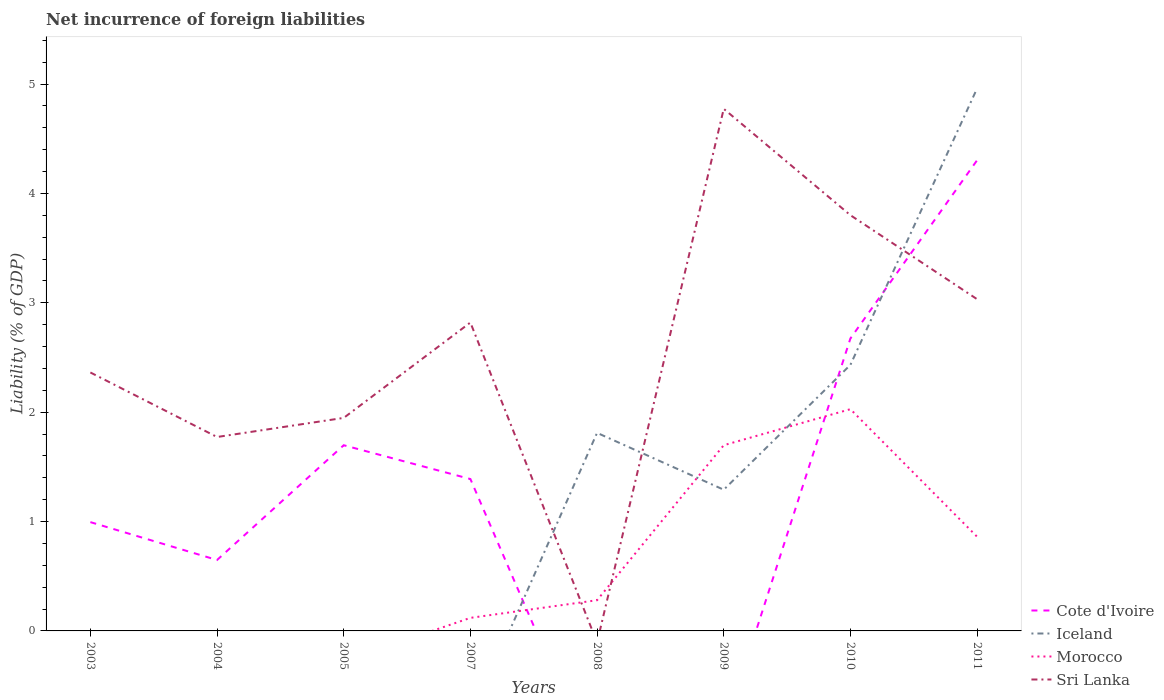Does the line corresponding to Iceland intersect with the line corresponding to Sri Lanka?
Provide a succinct answer. Yes. Is the number of lines equal to the number of legend labels?
Your answer should be very brief. No. What is the total net incurrence of foreign liabilities in Morocco in the graph?
Provide a succinct answer. -1.75. What is the difference between the highest and the second highest net incurrence of foreign liabilities in Cote d'Ivoire?
Make the answer very short. 4.3. How many lines are there?
Make the answer very short. 4. How many legend labels are there?
Give a very brief answer. 4. How are the legend labels stacked?
Keep it short and to the point. Vertical. What is the title of the graph?
Ensure brevity in your answer.  Net incurrence of foreign liabilities. What is the label or title of the Y-axis?
Make the answer very short. Liability (% of GDP). What is the Liability (% of GDP) in Cote d'Ivoire in 2003?
Your answer should be very brief. 0.99. What is the Liability (% of GDP) in Sri Lanka in 2003?
Provide a succinct answer. 2.36. What is the Liability (% of GDP) of Cote d'Ivoire in 2004?
Your response must be concise. 0.65. What is the Liability (% of GDP) of Iceland in 2004?
Your answer should be very brief. 0. What is the Liability (% of GDP) in Sri Lanka in 2004?
Provide a short and direct response. 1.77. What is the Liability (% of GDP) of Cote d'Ivoire in 2005?
Provide a succinct answer. 1.7. What is the Liability (% of GDP) in Morocco in 2005?
Your response must be concise. 0. What is the Liability (% of GDP) in Sri Lanka in 2005?
Provide a succinct answer. 1.95. What is the Liability (% of GDP) of Cote d'Ivoire in 2007?
Give a very brief answer. 1.39. What is the Liability (% of GDP) in Morocco in 2007?
Offer a terse response. 0.12. What is the Liability (% of GDP) of Sri Lanka in 2007?
Your response must be concise. 2.82. What is the Liability (% of GDP) in Cote d'Ivoire in 2008?
Keep it short and to the point. 0. What is the Liability (% of GDP) in Iceland in 2008?
Your response must be concise. 1.81. What is the Liability (% of GDP) in Morocco in 2008?
Offer a terse response. 0.28. What is the Liability (% of GDP) of Sri Lanka in 2008?
Ensure brevity in your answer.  0. What is the Liability (% of GDP) in Cote d'Ivoire in 2009?
Ensure brevity in your answer.  0. What is the Liability (% of GDP) of Iceland in 2009?
Offer a very short reply. 1.29. What is the Liability (% of GDP) in Morocco in 2009?
Offer a very short reply. 1.7. What is the Liability (% of GDP) of Sri Lanka in 2009?
Ensure brevity in your answer.  4.77. What is the Liability (% of GDP) of Cote d'Ivoire in 2010?
Ensure brevity in your answer.  2.67. What is the Liability (% of GDP) of Iceland in 2010?
Give a very brief answer. 2.43. What is the Liability (% of GDP) in Morocco in 2010?
Your answer should be compact. 2.03. What is the Liability (% of GDP) in Sri Lanka in 2010?
Your answer should be compact. 3.8. What is the Liability (% of GDP) of Cote d'Ivoire in 2011?
Your answer should be very brief. 4.3. What is the Liability (% of GDP) in Iceland in 2011?
Your answer should be very brief. 4.96. What is the Liability (% of GDP) in Morocco in 2011?
Keep it short and to the point. 0.86. What is the Liability (% of GDP) in Sri Lanka in 2011?
Give a very brief answer. 3.03. Across all years, what is the maximum Liability (% of GDP) in Cote d'Ivoire?
Provide a succinct answer. 4.3. Across all years, what is the maximum Liability (% of GDP) in Iceland?
Ensure brevity in your answer.  4.96. Across all years, what is the maximum Liability (% of GDP) of Morocco?
Keep it short and to the point. 2.03. Across all years, what is the maximum Liability (% of GDP) in Sri Lanka?
Make the answer very short. 4.77. Across all years, what is the minimum Liability (% of GDP) in Sri Lanka?
Provide a short and direct response. 0. What is the total Liability (% of GDP) of Cote d'Ivoire in the graph?
Your answer should be compact. 11.71. What is the total Liability (% of GDP) in Iceland in the graph?
Make the answer very short. 10.49. What is the total Liability (% of GDP) in Morocco in the graph?
Make the answer very short. 4.99. What is the total Liability (% of GDP) in Sri Lanka in the graph?
Ensure brevity in your answer.  20.51. What is the difference between the Liability (% of GDP) of Cote d'Ivoire in 2003 and that in 2004?
Ensure brevity in your answer.  0.35. What is the difference between the Liability (% of GDP) in Sri Lanka in 2003 and that in 2004?
Your answer should be compact. 0.59. What is the difference between the Liability (% of GDP) of Cote d'Ivoire in 2003 and that in 2005?
Your answer should be compact. -0.7. What is the difference between the Liability (% of GDP) of Sri Lanka in 2003 and that in 2005?
Offer a terse response. 0.42. What is the difference between the Liability (% of GDP) in Cote d'Ivoire in 2003 and that in 2007?
Make the answer very short. -0.39. What is the difference between the Liability (% of GDP) in Sri Lanka in 2003 and that in 2007?
Make the answer very short. -0.46. What is the difference between the Liability (% of GDP) in Sri Lanka in 2003 and that in 2009?
Your answer should be very brief. -2.41. What is the difference between the Liability (% of GDP) of Cote d'Ivoire in 2003 and that in 2010?
Keep it short and to the point. -1.68. What is the difference between the Liability (% of GDP) of Sri Lanka in 2003 and that in 2010?
Your response must be concise. -1.44. What is the difference between the Liability (% of GDP) in Cote d'Ivoire in 2003 and that in 2011?
Provide a short and direct response. -3.31. What is the difference between the Liability (% of GDP) in Sri Lanka in 2003 and that in 2011?
Your response must be concise. -0.67. What is the difference between the Liability (% of GDP) of Cote d'Ivoire in 2004 and that in 2005?
Your answer should be compact. -1.05. What is the difference between the Liability (% of GDP) in Sri Lanka in 2004 and that in 2005?
Give a very brief answer. -0.17. What is the difference between the Liability (% of GDP) in Cote d'Ivoire in 2004 and that in 2007?
Keep it short and to the point. -0.74. What is the difference between the Liability (% of GDP) in Sri Lanka in 2004 and that in 2007?
Your answer should be very brief. -1.05. What is the difference between the Liability (% of GDP) of Sri Lanka in 2004 and that in 2009?
Your answer should be compact. -3. What is the difference between the Liability (% of GDP) of Cote d'Ivoire in 2004 and that in 2010?
Your answer should be compact. -2.03. What is the difference between the Liability (% of GDP) in Sri Lanka in 2004 and that in 2010?
Give a very brief answer. -2.03. What is the difference between the Liability (% of GDP) of Cote d'Ivoire in 2004 and that in 2011?
Give a very brief answer. -3.65. What is the difference between the Liability (% of GDP) in Sri Lanka in 2004 and that in 2011?
Provide a short and direct response. -1.26. What is the difference between the Liability (% of GDP) of Cote d'Ivoire in 2005 and that in 2007?
Offer a terse response. 0.31. What is the difference between the Liability (% of GDP) in Sri Lanka in 2005 and that in 2007?
Provide a short and direct response. -0.87. What is the difference between the Liability (% of GDP) in Sri Lanka in 2005 and that in 2009?
Provide a short and direct response. -2.83. What is the difference between the Liability (% of GDP) of Cote d'Ivoire in 2005 and that in 2010?
Make the answer very short. -0.98. What is the difference between the Liability (% of GDP) in Sri Lanka in 2005 and that in 2010?
Provide a short and direct response. -1.85. What is the difference between the Liability (% of GDP) in Cote d'Ivoire in 2005 and that in 2011?
Ensure brevity in your answer.  -2.61. What is the difference between the Liability (% of GDP) in Sri Lanka in 2005 and that in 2011?
Ensure brevity in your answer.  -1.09. What is the difference between the Liability (% of GDP) in Morocco in 2007 and that in 2008?
Ensure brevity in your answer.  -0.16. What is the difference between the Liability (% of GDP) in Morocco in 2007 and that in 2009?
Your answer should be very brief. -1.58. What is the difference between the Liability (% of GDP) of Sri Lanka in 2007 and that in 2009?
Ensure brevity in your answer.  -1.95. What is the difference between the Liability (% of GDP) in Cote d'Ivoire in 2007 and that in 2010?
Make the answer very short. -1.29. What is the difference between the Liability (% of GDP) in Morocco in 2007 and that in 2010?
Give a very brief answer. -1.91. What is the difference between the Liability (% of GDP) of Sri Lanka in 2007 and that in 2010?
Your answer should be compact. -0.98. What is the difference between the Liability (% of GDP) of Cote d'Ivoire in 2007 and that in 2011?
Your response must be concise. -2.91. What is the difference between the Liability (% of GDP) in Morocco in 2007 and that in 2011?
Your response must be concise. -0.74. What is the difference between the Liability (% of GDP) of Sri Lanka in 2007 and that in 2011?
Your response must be concise. -0.21. What is the difference between the Liability (% of GDP) in Iceland in 2008 and that in 2009?
Offer a terse response. 0.52. What is the difference between the Liability (% of GDP) in Morocco in 2008 and that in 2009?
Provide a short and direct response. -1.42. What is the difference between the Liability (% of GDP) in Iceland in 2008 and that in 2010?
Your answer should be very brief. -0.62. What is the difference between the Liability (% of GDP) of Morocco in 2008 and that in 2010?
Offer a terse response. -1.75. What is the difference between the Liability (% of GDP) of Iceland in 2008 and that in 2011?
Your answer should be compact. -3.15. What is the difference between the Liability (% of GDP) in Morocco in 2008 and that in 2011?
Offer a very short reply. -0.58. What is the difference between the Liability (% of GDP) of Iceland in 2009 and that in 2010?
Give a very brief answer. -1.14. What is the difference between the Liability (% of GDP) of Morocco in 2009 and that in 2010?
Offer a very short reply. -0.33. What is the difference between the Liability (% of GDP) in Sri Lanka in 2009 and that in 2010?
Make the answer very short. 0.97. What is the difference between the Liability (% of GDP) of Iceland in 2009 and that in 2011?
Provide a short and direct response. -3.67. What is the difference between the Liability (% of GDP) in Morocco in 2009 and that in 2011?
Provide a succinct answer. 0.84. What is the difference between the Liability (% of GDP) in Sri Lanka in 2009 and that in 2011?
Ensure brevity in your answer.  1.74. What is the difference between the Liability (% of GDP) in Cote d'Ivoire in 2010 and that in 2011?
Your response must be concise. -1.63. What is the difference between the Liability (% of GDP) in Iceland in 2010 and that in 2011?
Provide a short and direct response. -2.53. What is the difference between the Liability (% of GDP) of Morocco in 2010 and that in 2011?
Provide a short and direct response. 1.17. What is the difference between the Liability (% of GDP) of Sri Lanka in 2010 and that in 2011?
Make the answer very short. 0.77. What is the difference between the Liability (% of GDP) of Cote d'Ivoire in 2003 and the Liability (% of GDP) of Sri Lanka in 2004?
Offer a terse response. -0.78. What is the difference between the Liability (% of GDP) in Cote d'Ivoire in 2003 and the Liability (% of GDP) in Sri Lanka in 2005?
Give a very brief answer. -0.95. What is the difference between the Liability (% of GDP) of Cote d'Ivoire in 2003 and the Liability (% of GDP) of Morocco in 2007?
Your response must be concise. 0.88. What is the difference between the Liability (% of GDP) of Cote d'Ivoire in 2003 and the Liability (% of GDP) of Sri Lanka in 2007?
Your response must be concise. -1.82. What is the difference between the Liability (% of GDP) in Cote d'Ivoire in 2003 and the Liability (% of GDP) in Iceland in 2008?
Give a very brief answer. -0.82. What is the difference between the Liability (% of GDP) of Cote d'Ivoire in 2003 and the Liability (% of GDP) of Morocco in 2008?
Give a very brief answer. 0.71. What is the difference between the Liability (% of GDP) of Cote d'Ivoire in 2003 and the Liability (% of GDP) of Iceland in 2009?
Provide a succinct answer. -0.3. What is the difference between the Liability (% of GDP) in Cote d'Ivoire in 2003 and the Liability (% of GDP) in Morocco in 2009?
Provide a short and direct response. -0.7. What is the difference between the Liability (% of GDP) in Cote d'Ivoire in 2003 and the Liability (% of GDP) in Sri Lanka in 2009?
Keep it short and to the point. -3.78. What is the difference between the Liability (% of GDP) of Cote d'Ivoire in 2003 and the Liability (% of GDP) of Iceland in 2010?
Keep it short and to the point. -1.44. What is the difference between the Liability (% of GDP) of Cote d'Ivoire in 2003 and the Liability (% of GDP) of Morocco in 2010?
Provide a succinct answer. -1.03. What is the difference between the Liability (% of GDP) in Cote d'Ivoire in 2003 and the Liability (% of GDP) in Sri Lanka in 2010?
Ensure brevity in your answer.  -2.81. What is the difference between the Liability (% of GDP) in Cote d'Ivoire in 2003 and the Liability (% of GDP) in Iceland in 2011?
Your response must be concise. -3.97. What is the difference between the Liability (% of GDP) in Cote d'Ivoire in 2003 and the Liability (% of GDP) in Morocco in 2011?
Make the answer very short. 0.13. What is the difference between the Liability (% of GDP) of Cote d'Ivoire in 2003 and the Liability (% of GDP) of Sri Lanka in 2011?
Ensure brevity in your answer.  -2.04. What is the difference between the Liability (% of GDP) of Cote d'Ivoire in 2004 and the Liability (% of GDP) of Sri Lanka in 2005?
Your response must be concise. -1.3. What is the difference between the Liability (% of GDP) in Cote d'Ivoire in 2004 and the Liability (% of GDP) in Morocco in 2007?
Offer a very short reply. 0.53. What is the difference between the Liability (% of GDP) of Cote d'Ivoire in 2004 and the Liability (% of GDP) of Sri Lanka in 2007?
Offer a very short reply. -2.17. What is the difference between the Liability (% of GDP) of Cote d'Ivoire in 2004 and the Liability (% of GDP) of Iceland in 2008?
Your answer should be compact. -1.16. What is the difference between the Liability (% of GDP) in Cote d'Ivoire in 2004 and the Liability (% of GDP) in Morocco in 2008?
Offer a terse response. 0.37. What is the difference between the Liability (% of GDP) in Cote d'Ivoire in 2004 and the Liability (% of GDP) in Iceland in 2009?
Your answer should be compact. -0.64. What is the difference between the Liability (% of GDP) of Cote d'Ivoire in 2004 and the Liability (% of GDP) of Morocco in 2009?
Provide a short and direct response. -1.05. What is the difference between the Liability (% of GDP) of Cote d'Ivoire in 2004 and the Liability (% of GDP) of Sri Lanka in 2009?
Offer a terse response. -4.12. What is the difference between the Liability (% of GDP) of Cote d'Ivoire in 2004 and the Liability (% of GDP) of Iceland in 2010?
Offer a very short reply. -1.78. What is the difference between the Liability (% of GDP) of Cote d'Ivoire in 2004 and the Liability (% of GDP) of Morocco in 2010?
Your response must be concise. -1.38. What is the difference between the Liability (% of GDP) in Cote d'Ivoire in 2004 and the Liability (% of GDP) in Sri Lanka in 2010?
Provide a succinct answer. -3.15. What is the difference between the Liability (% of GDP) in Cote d'Ivoire in 2004 and the Liability (% of GDP) in Iceland in 2011?
Offer a very short reply. -4.31. What is the difference between the Liability (% of GDP) of Cote d'Ivoire in 2004 and the Liability (% of GDP) of Morocco in 2011?
Offer a very short reply. -0.21. What is the difference between the Liability (% of GDP) in Cote d'Ivoire in 2004 and the Liability (% of GDP) in Sri Lanka in 2011?
Provide a succinct answer. -2.38. What is the difference between the Liability (% of GDP) in Cote d'Ivoire in 2005 and the Liability (% of GDP) in Morocco in 2007?
Your response must be concise. 1.58. What is the difference between the Liability (% of GDP) of Cote d'Ivoire in 2005 and the Liability (% of GDP) of Sri Lanka in 2007?
Offer a very short reply. -1.12. What is the difference between the Liability (% of GDP) of Cote d'Ivoire in 2005 and the Liability (% of GDP) of Iceland in 2008?
Make the answer very short. -0.11. What is the difference between the Liability (% of GDP) in Cote d'Ivoire in 2005 and the Liability (% of GDP) in Morocco in 2008?
Your answer should be compact. 1.42. What is the difference between the Liability (% of GDP) in Cote d'Ivoire in 2005 and the Liability (% of GDP) in Iceland in 2009?
Offer a very short reply. 0.41. What is the difference between the Liability (% of GDP) in Cote d'Ivoire in 2005 and the Liability (% of GDP) in Morocco in 2009?
Keep it short and to the point. -0. What is the difference between the Liability (% of GDP) in Cote d'Ivoire in 2005 and the Liability (% of GDP) in Sri Lanka in 2009?
Provide a succinct answer. -3.08. What is the difference between the Liability (% of GDP) in Cote d'Ivoire in 2005 and the Liability (% of GDP) in Iceland in 2010?
Offer a very short reply. -0.73. What is the difference between the Liability (% of GDP) of Cote d'Ivoire in 2005 and the Liability (% of GDP) of Morocco in 2010?
Your response must be concise. -0.33. What is the difference between the Liability (% of GDP) in Cote d'Ivoire in 2005 and the Liability (% of GDP) in Sri Lanka in 2010?
Your answer should be compact. -2.1. What is the difference between the Liability (% of GDP) of Cote d'Ivoire in 2005 and the Liability (% of GDP) of Iceland in 2011?
Your answer should be compact. -3.26. What is the difference between the Liability (% of GDP) in Cote d'Ivoire in 2005 and the Liability (% of GDP) in Morocco in 2011?
Keep it short and to the point. 0.84. What is the difference between the Liability (% of GDP) of Cote d'Ivoire in 2005 and the Liability (% of GDP) of Sri Lanka in 2011?
Provide a succinct answer. -1.34. What is the difference between the Liability (% of GDP) of Cote d'Ivoire in 2007 and the Liability (% of GDP) of Iceland in 2008?
Offer a terse response. -0.42. What is the difference between the Liability (% of GDP) in Cote d'Ivoire in 2007 and the Liability (% of GDP) in Morocco in 2008?
Your response must be concise. 1.11. What is the difference between the Liability (% of GDP) of Cote d'Ivoire in 2007 and the Liability (% of GDP) of Iceland in 2009?
Keep it short and to the point. 0.1. What is the difference between the Liability (% of GDP) in Cote d'Ivoire in 2007 and the Liability (% of GDP) in Morocco in 2009?
Ensure brevity in your answer.  -0.31. What is the difference between the Liability (% of GDP) in Cote d'Ivoire in 2007 and the Liability (% of GDP) in Sri Lanka in 2009?
Give a very brief answer. -3.38. What is the difference between the Liability (% of GDP) of Morocco in 2007 and the Liability (% of GDP) of Sri Lanka in 2009?
Your answer should be very brief. -4.65. What is the difference between the Liability (% of GDP) in Cote d'Ivoire in 2007 and the Liability (% of GDP) in Iceland in 2010?
Give a very brief answer. -1.04. What is the difference between the Liability (% of GDP) in Cote d'Ivoire in 2007 and the Liability (% of GDP) in Morocco in 2010?
Ensure brevity in your answer.  -0.64. What is the difference between the Liability (% of GDP) in Cote d'Ivoire in 2007 and the Liability (% of GDP) in Sri Lanka in 2010?
Offer a terse response. -2.41. What is the difference between the Liability (% of GDP) of Morocco in 2007 and the Liability (% of GDP) of Sri Lanka in 2010?
Your answer should be very brief. -3.68. What is the difference between the Liability (% of GDP) in Cote d'Ivoire in 2007 and the Liability (% of GDP) in Iceland in 2011?
Keep it short and to the point. -3.57. What is the difference between the Liability (% of GDP) of Cote d'Ivoire in 2007 and the Liability (% of GDP) of Morocco in 2011?
Offer a terse response. 0.53. What is the difference between the Liability (% of GDP) of Cote d'Ivoire in 2007 and the Liability (% of GDP) of Sri Lanka in 2011?
Your answer should be compact. -1.64. What is the difference between the Liability (% of GDP) of Morocco in 2007 and the Liability (% of GDP) of Sri Lanka in 2011?
Keep it short and to the point. -2.91. What is the difference between the Liability (% of GDP) of Iceland in 2008 and the Liability (% of GDP) of Morocco in 2009?
Keep it short and to the point. 0.11. What is the difference between the Liability (% of GDP) of Iceland in 2008 and the Liability (% of GDP) of Sri Lanka in 2009?
Provide a short and direct response. -2.96. What is the difference between the Liability (% of GDP) of Morocco in 2008 and the Liability (% of GDP) of Sri Lanka in 2009?
Provide a short and direct response. -4.49. What is the difference between the Liability (% of GDP) of Iceland in 2008 and the Liability (% of GDP) of Morocco in 2010?
Your response must be concise. -0.22. What is the difference between the Liability (% of GDP) of Iceland in 2008 and the Liability (% of GDP) of Sri Lanka in 2010?
Offer a very short reply. -1.99. What is the difference between the Liability (% of GDP) in Morocco in 2008 and the Liability (% of GDP) in Sri Lanka in 2010?
Offer a terse response. -3.52. What is the difference between the Liability (% of GDP) of Iceland in 2008 and the Liability (% of GDP) of Morocco in 2011?
Make the answer very short. 0.95. What is the difference between the Liability (% of GDP) in Iceland in 2008 and the Liability (% of GDP) in Sri Lanka in 2011?
Make the answer very short. -1.22. What is the difference between the Liability (% of GDP) in Morocco in 2008 and the Liability (% of GDP) in Sri Lanka in 2011?
Your answer should be compact. -2.75. What is the difference between the Liability (% of GDP) in Iceland in 2009 and the Liability (% of GDP) in Morocco in 2010?
Give a very brief answer. -0.74. What is the difference between the Liability (% of GDP) of Iceland in 2009 and the Liability (% of GDP) of Sri Lanka in 2010?
Keep it short and to the point. -2.51. What is the difference between the Liability (% of GDP) of Morocco in 2009 and the Liability (% of GDP) of Sri Lanka in 2010?
Your answer should be compact. -2.1. What is the difference between the Liability (% of GDP) of Iceland in 2009 and the Liability (% of GDP) of Morocco in 2011?
Offer a very short reply. 0.43. What is the difference between the Liability (% of GDP) of Iceland in 2009 and the Liability (% of GDP) of Sri Lanka in 2011?
Offer a very short reply. -1.74. What is the difference between the Liability (% of GDP) in Morocco in 2009 and the Liability (% of GDP) in Sri Lanka in 2011?
Your answer should be very brief. -1.34. What is the difference between the Liability (% of GDP) in Cote d'Ivoire in 2010 and the Liability (% of GDP) in Iceland in 2011?
Keep it short and to the point. -2.29. What is the difference between the Liability (% of GDP) of Cote d'Ivoire in 2010 and the Liability (% of GDP) of Morocco in 2011?
Provide a short and direct response. 1.81. What is the difference between the Liability (% of GDP) of Cote d'Ivoire in 2010 and the Liability (% of GDP) of Sri Lanka in 2011?
Your answer should be compact. -0.36. What is the difference between the Liability (% of GDP) of Iceland in 2010 and the Liability (% of GDP) of Morocco in 2011?
Make the answer very short. 1.57. What is the difference between the Liability (% of GDP) in Iceland in 2010 and the Liability (% of GDP) in Sri Lanka in 2011?
Make the answer very short. -0.6. What is the difference between the Liability (% of GDP) of Morocco in 2010 and the Liability (% of GDP) of Sri Lanka in 2011?
Your answer should be compact. -1.01. What is the average Liability (% of GDP) in Cote d'Ivoire per year?
Provide a short and direct response. 1.46. What is the average Liability (% of GDP) of Iceland per year?
Offer a terse response. 1.31. What is the average Liability (% of GDP) in Morocco per year?
Your response must be concise. 0.62. What is the average Liability (% of GDP) of Sri Lanka per year?
Your answer should be compact. 2.56. In the year 2003, what is the difference between the Liability (% of GDP) of Cote d'Ivoire and Liability (% of GDP) of Sri Lanka?
Keep it short and to the point. -1.37. In the year 2004, what is the difference between the Liability (% of GDP) in Cote d'Ivoire and Liability (% of GDP) in Sri Lanka?
Provide a short and direct response. -1.12. In the year 2005, what is the difference between the Liability (% of GDP) of Cote d'Ivoire and Liability (% of GDP) of Sri Lanka?
Your response must be concise. -0.25. In the year 2007, what is the difference between the Liability (% of GDP) in Cote d'Ivoire and Liability (% of GDP) in Morocco?
Offer a very short reply. 1.27. In the year 2007, what is the difference between the Liability (% of GDP) in Cote d'Ivoire and Liability (% of GDP) in Sri Lanka?
Make the answer very short. -1.43. In the year 2007, what is the difference between the Liability (% of GDP) of Morocco and Liability (% of GDP) of Sri Lanka?
Ensure brevity in your answer.  -2.7. In the year 2008, what is the difference between the Liability (% of GDP) of Iceland and Liability (% of GDP) of Morocco?
Provide a succinct answer. 1.53. In the year 2009, what is the difference between the Liability (% of GDP) in Iceland and Liability (% of GDP) in Morocco?
Keep it short and to the point. -0.41. In the year 2009, what is the difference between the Liability (% of GDP) of Iceland and Liability (% of GDP) of Sri Lanka?
Make the answer very short. -3.48. In the year 2009, what is the difference between the Liability (% of GDP) of Morocco and Liability (% of GDP) of Sri Lanka?
Keep it short and to the point. -3.08. In the year 2010, what is the difference between the Liability (% of GDP) in Cote d'Ivoire and Liability (% of GDP) in Iceland?
Make the answer very short. 0.24. In the year 2010, what is the difference between the Liability (% of GDP) of Cote d'Ivoire and Liability (% of GDP) of Morocco?
Offer a terse response. 0.65. In the year 2010, what is the difference between the Liability (% of GDP) of Cote d'Ivoire and Liability (% of GDP) of Sri Lanka?
Your response must be concise. -1.13. In the year 2010, what is the difference between the Liability (% of GDP) in Iceland and Liability (% of GDP) in Morocco?
Your answer should be compact. 0.41. In the year 2010, what is the difference between the Liability (% of GDP) of Iceland and Liability (% of GDP) of Sri Lanka?
Your answer should be very brief. -1.37. In the year 2010, what is the difference between the Liability (% of GDP) in Morocco and Liability (% of GDP) in Sri Lanka?
Your answer should be very brief. -1.77. In the year 2011, what is the difference between the Liability (% of GDP) of Cote d'Ivoire and Liability (% of GDP) of Iceland?
Your answer should be compact. -0.66. In the year 2011, what is the difference between the Liability (% of GDP) in Cote d'Ivoire and Liability (% of GDP) in Morocco?
Your answer should be very brief. 3.44. In the year 2011, what is the difference between the Liability (% of GDP) of Cote d'Ivoire and Liability (% of GDP) of Sri Lanka?
Give a very brief answer. 1.27. In the year 2011, what is the difference between the Liability (% of GDP) in Iceland and Liability (% of GDP) in Morocco?
Your answer should be compact. 4.1. In the year 2011, what is the difference between the Liability (% of GDP) of Iceland and Liability (% of GDP) of Sri Lanka?
Offer a terse response. 1.93. In the year 2011, what is the difference between the Liability (% of GDP) in Morocco and Liability (% of GDP) in Sri Lanka?
Your response must be concise. -2.17. What is the ratio of the Liability (% of GDP) of Cote d'Ivoire in 2003 to that in 2004?
Your response must be concise. 1.53. What is the ratio of the Liability (% of GDP) in Sri Lanka in 2003 to that in 2004?
Provide a succinct answer. 1.33. What is the ratio of the Liability (% of GDP) of Cote d'Ivoire in 2003 to that in 2005?
Offer a terse response. 0.59. What is the ratio of the Liability (% of GDP) of Sri Lanka in 2003 to that in 2005?
Provide a succinct answer. 1.21. What is the ratio of the Liability (% of GDP) of Cote d'Ivoire in 2003 to that in 2007?
Your answer should be compact. 0.72. What is the ratio of the Liability (% of GDP) of Sri Lanka in 2003 to that in 2007?
Provide a succinct answer. 0.84. What is the ratio of the Liability (% of GDP) in Sri Lanka in 2003 to that in 2009?
Provide a succinct answer. 0.49. What is the ratio of the Liability (% of GDP) of Cote d'Ivoire in 2003 to that in 2010?
Give a very brief answer. 0.37. What is the ratio of the Liability (% of GDP) in Sri Lanka in 2003 to that in 2010?
Your answer should be very brief. 0.62. What is the ratio of the Liability (% of GDP) of Cote d'Ivoire in 2003 to that in 2011?
Offer a very short reply. 0.23. What is the ratio of the Liability (% of GDP) in Sri Lanka in 2003 to that in 2011?
Your answer should be compact. 0.78. What is the ratio of the Liability (% of GDP) of Cote d'Ivoire in 2004 to that in 2005?
Your answer should be compact. 0.38. What is the ratio of the Liability (% of GDP) in Sri Lanka in 2004 to that in 2005?
Your answer should be compact. 0.91. What is the ratio of the Liability (% of GDP) of Cote d'Ivoire in 2004 to that in 2007?
Ensure brevity in your answer.  0.47. What is the ratio of the Liability (% of GDP) in Sri Lanka in 2004 to that in 2007?
Your answer should be compact. 0.63. What is the ratio of the Liability (% of GDP) of Sri Lanka in 2004 to that in 2009?
Provide a short and direct response. 0.37. What is the ratio of the Liability (% of GDP) in Cote d'Ivoire in 2004 to that in 2010?
Offer a terse response. 0.24. What is the ratio of the Liability (% of GDP) of Sri Lanka in 2004 to that in 2010?
Provide a short and direct response. 0.47. What is the ratio of the Liability (% of GDP) in Cote d'Ivoire in 2004 to that in 2011?
Keep it short and to the point. 0.15. What is the ratio of the Liability (% of GDP) of Sri Lanka in 2004 to that in 2011?
Ensure brevity in your answer.  0.58. What is the ratio of the Liability (% of GDP) of Cote d'Ivoire in 2005 to that in 2007?
Keep it short and to the point. 1.22. What is the ratio of the Liability (% of GDP) in Sri Lanka in 2005 to that in 2007?
Give a very brief answer. 0.69. What is the ratio of the Liability (% of GDP) of Sri Lanka in 2005 to that in 2009?
Offer a very short reply. 0.41. What is the ratio of the Liability (% of GDP) of Cote d'Ivoire in 2005 to that in 2010?
Provide a short and direct response. 0.63. What is the ratio of the Liability (% of GDP) in Sri Lanka in 2005 to that in 2010?
Your answer should be very brief. 0.51. What is the ratio of the Liability (% of GDP) of Cote d'Ivoire in 2005 to that in 2011?
Your response must be concise. 0.39. What is the ratio of the Liability (% of GDP) of Sri Lanka in 2005 to that in 2011?
Give a very brief answer. 0.64. What is the ratio of the Liability (% of GDP) of Morocco in 2007 to that in 2008?
Make the answer very short. 0.42. What is the ratio of the Liability (% of GDP) in Morocco in 2007 to that in 2009?
Your answer should be very brief. 0.07. What is the ratio of the Liability (% of GDP) in Sri Lanka in 2007 to that in 2009?
Ensure brevity in your answer.  0.59. What is the ratio of the Liability (% of GDP) in Cote d'Ivoire in 2007 to that in 2010?
Provide a succinct answer. 0.52. What is the ratio of the Liability (% of GDP) in Morocco in 2007 to that in 2010?
Your answer should be very brief. 0.06. What is the ratio of the Liability (% of GDP) in Sri Lanka in 2007 to that in 2010?
Make the answer very short. 0.74. What is the ratio of the Liability (% of GDP) in Cote d'Ivoire in 2007 to that in 2011?
Keep it short and to the point. 0.32. What is the ratio of the Liability (% of GDP) in Morocco in 2007 to that in 2011?
Provide a short and direct response. 0.14. What is the ratio of the Liability (% of GDP) in Sri Lanka in 2007 to that in 2011?
Make the answer very short. 0.93. What is the ratio of the Liability (% of GDP) in Iceland in 2008 to that in 2009?
Your answer should be very brief. 1.4. What is the ratio of the Liability (% of GDP) in Morocco in 2008 to that in 2009?
Ensure brevity in your answer.  0.17. What is the ratio of the Liability (% of GDP) in Iceland in 2008 to that in 2010?
Provide a short and direct response. 0.74. What is the ratio of the Liability (% of GDP) in Morocco in 2008 to that in 2010?
Offer a terse response. 0.14. What is the ratio of the Liability (% of GDP) in Iceland in 2008 to that in 2011?
Offer a terse response. 0.37. What is the ratio of the Liability (% of GDP) in Morocco in 2008 to that in 2011?
Keep it short and to the point. 0.33. What is the ratio of the Liability (% of GDP) of Iceland in 2009 to that in 2010?
Your answer should be compact. 0.53. What is the ratio of the Liability (% of GDP) in Morocco in 2009 to that in 2010?
Offer a very short reply. 0.84. What is the ratio of the Liability (% of GDP) in Sri Lanka in 2009 to that in 2010?
Offer a very short reply. 1.26. What is the ratio of the Liability (% of GDP) of Iceland in 2009 to that in 2011?
Offer a very short reply. 0.26. What is the ratio of the Liability (% of GDP) in Morocco in 2009 to that in 2011?
Your response must be concise. 1.97. What is the ratio of the Liability (% of GDP) in Sri Lanka in 2009 to that in 2011?
Offer a terse response. 1.57. What is the ratio of the Liability (% of GDP) of Cote d'Ivoire in 2010 to that in 2011?
Provide a short and direct response. 0.62. What is the ratio of the Liability (% of GDP) of Iceland in 2010 to that in 2011?
Ensure brevity in your answer.  0.49. What is the ratio of the Liability (% of GDP) in Morocco in 2010 to that in 2011?
Ensure brevity in your answer.  2.35. What is the ratio of the Liability (% of GDP) of Sri Lanka in 2010 to that in 2011?
Make the answer very short. 1.25. What is the difference between the highest and the second highest Liability (% of GDP) of Cote d'Ivoire?
Give a very brief answer. 1.63. What is the difference between the highest and the second highest Liability (% of GDP) in Iceland?
Your answer should be compact. 2.53. What is the difference between the highest and the second highest Liability (% of GDP) in Morocco?
Your answer should be compact. 0.33. What is the difference between the highest and the second highest Liability (% of GDP) in Sri Lanka?
Make the answer very short. 0.97. What is the difference between the highest and the lowest Liability (% of GDP) of Cote d'Ivoire?
Your response must be concise. 4.3. What is the difference between the highest and the lowest Liability (% of GDP) of Iceland?
Offer a very short reply. 4.96. What is the difference between the highest and the lowest Liability (% of GDP) of Morocco?
Ensure brevity in your answer.  2.03. What is the difference between the highest and the lowest Liability (% of GDP) of Sri Lanka?
Ensure brevity in your answer.  4.77. 